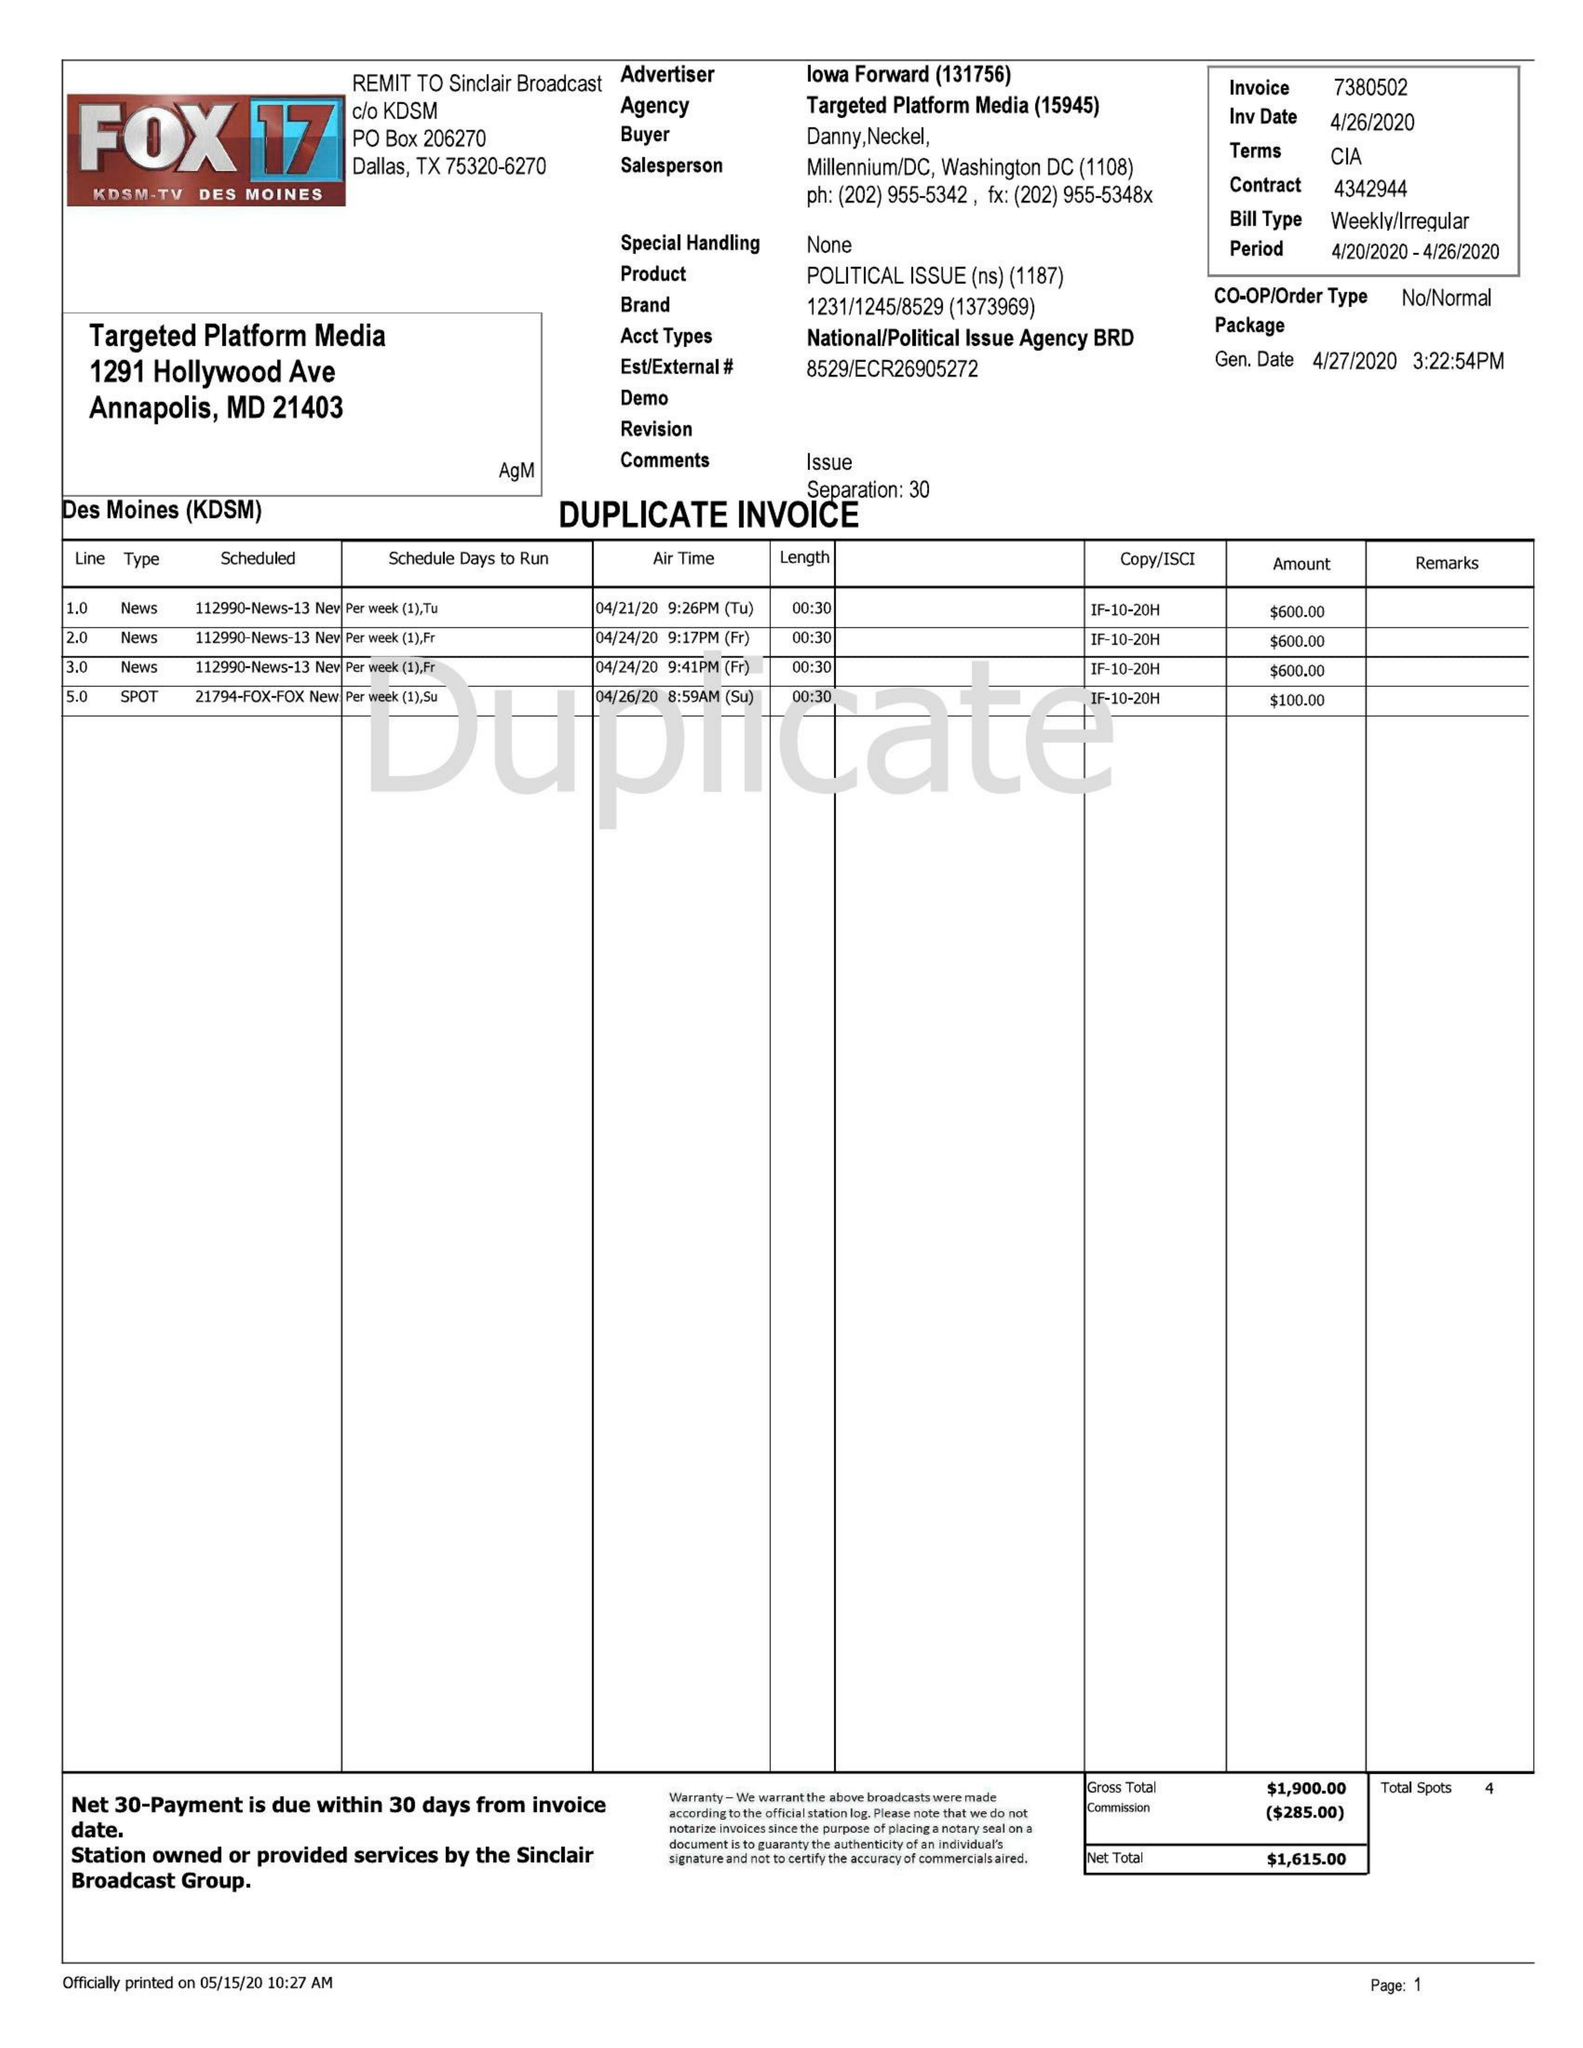What is the value for the advertiser?
Answer the question using a single word or phrase. LOWA FORWARD 